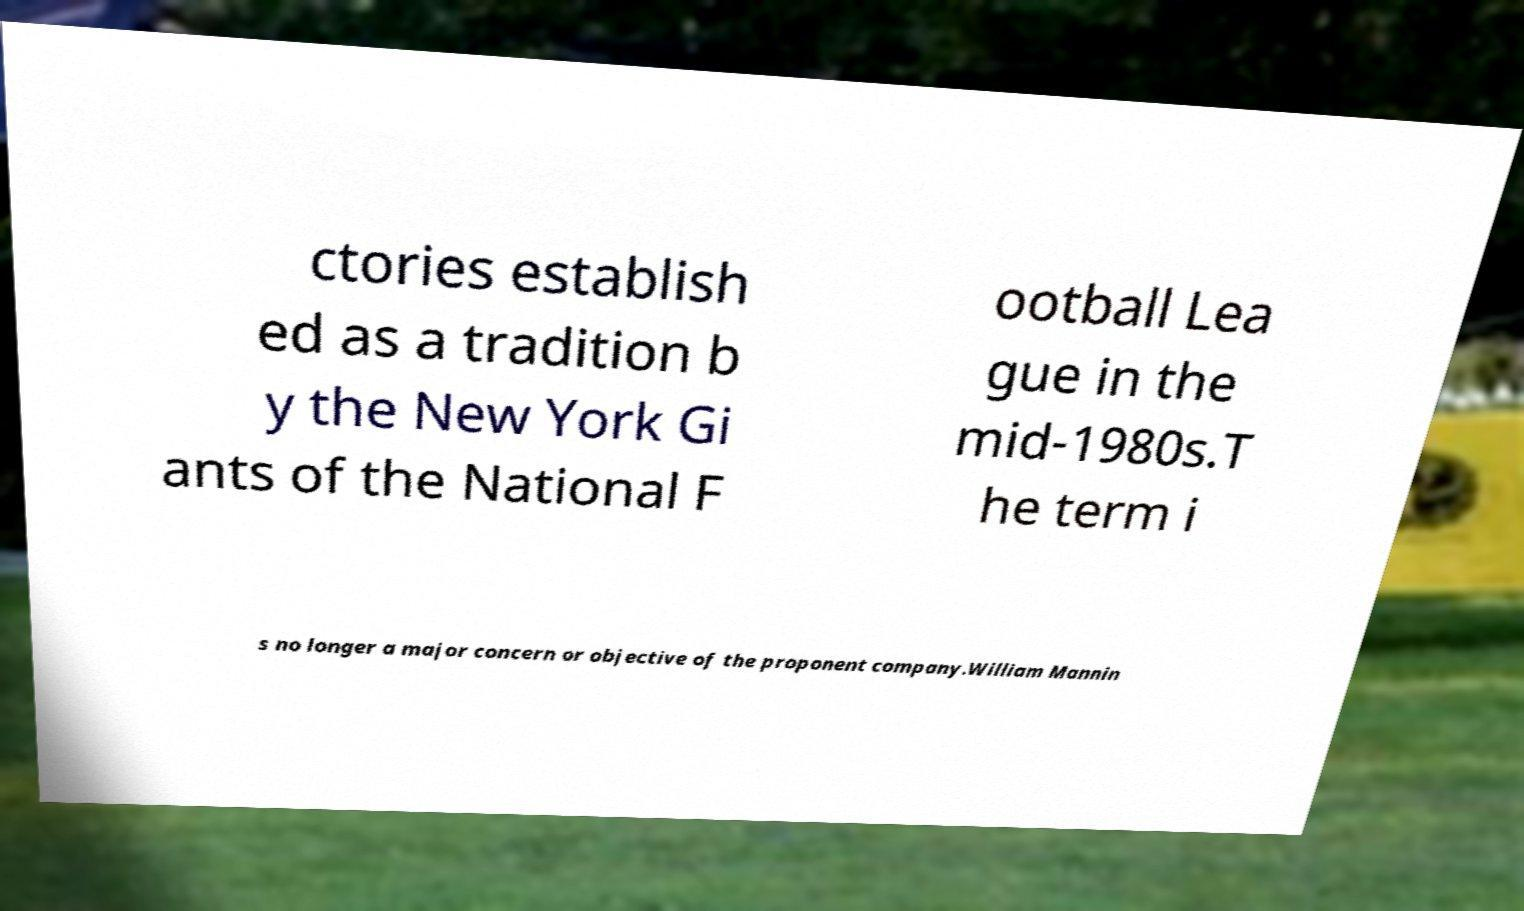I need the written content from this picture converted into text. Can you do that? ctories establish ed as a tradition b y the New York Gi ants of the National F ootball Lea gue in the mid-1980s.T he term i s no longer a major concern or objective of the proponent company.William Mannin 